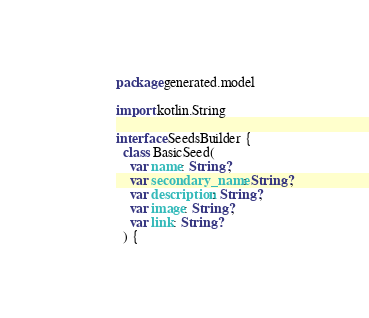<code> <loc_0><loc_0><loc_500><loc_500><_Kotlin_>package generated.model

import kotlin.String

interface SeedsBuilder {
  class BasicSeed(
    var name: String?,
    var secondary_name: String?,
    var description: String?,
    var image: String?,
    var link: String?
  ) {</code> 